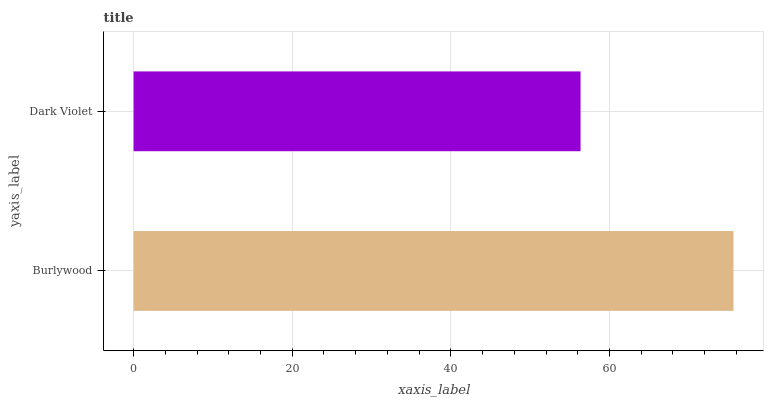Is Dark Violet the minimum?
Answer yes or no. Yes. Is Burlywood the maximum?
Answer yes or no. Yes. Is Dark Violet the maximum?
Answer yes or no. No. Is Burlywood greater than Dark Violet?
Answer yes or no. Yes. Is Dark Violet less than Burlywood?
Answer yes or no. Yes. Is Dark Violet greater than Burlywood?
Answer yes or no. No. Is Burlywood less than Dark Violet?
Answer yes or no. No. Is Burlywood the high median?
Answer yes or no. Yes. Is Dark Violet the low median?
Answer yes or no. Yes. Is Dark Violet the high median?
Answer yes or no. No. Is Burlywood the low median?
Answer yes or no. No. 